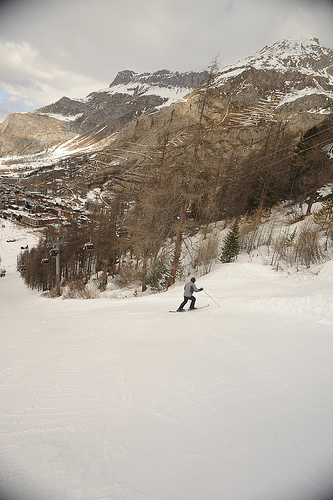Can you describe the weather conditions in the skiing area? The sky appears overcast with a consistent layer of clouds, suggesting cold and possibly snowy weather conditions, which are typical for a skiing area during the winter season. Would these conditions be considered good for skiing? Yes, overcast skies often indicate stable temperatures, and the ample snow coverage on the slopes suggests that conditions are indeed good for skiing, providing a soft snow surface for skiers. 